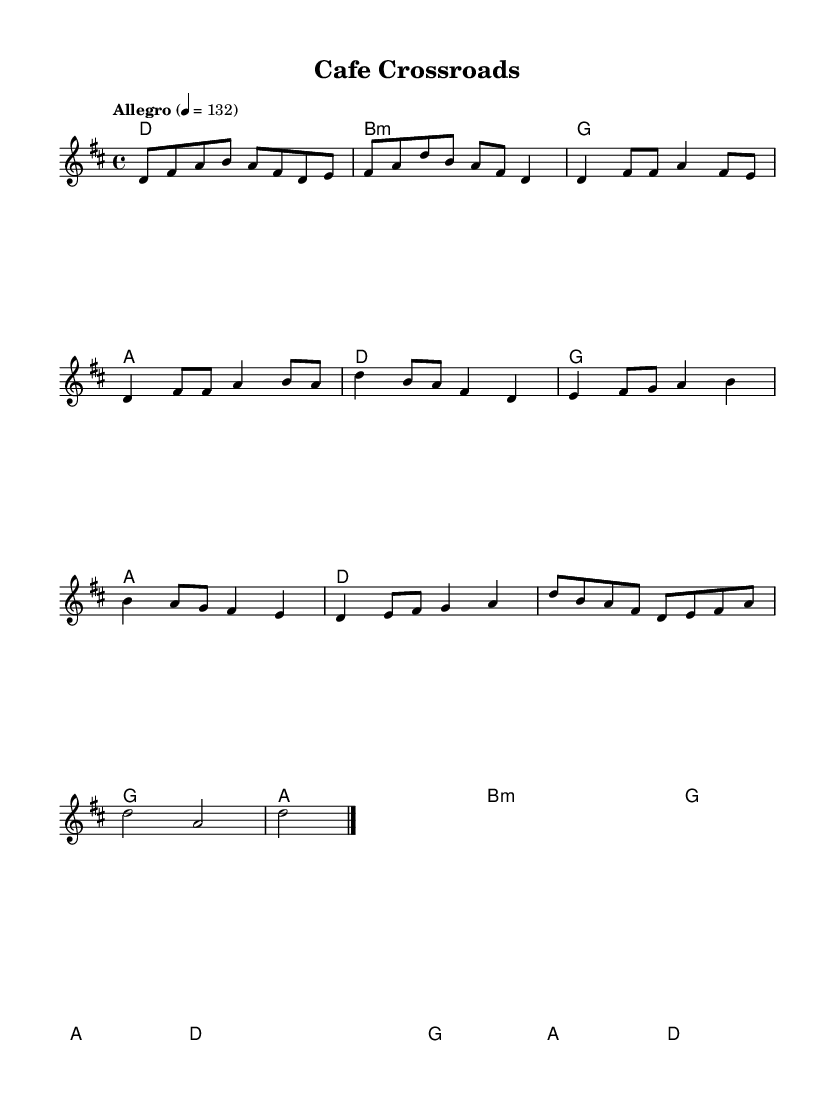What is the key signature of this music? The key signature is D major, indicated by two sharps (F# and C#) in the beginning of the staff.
Answer: D major What is the time signature of this piece? The time signature is 4/4, meaning there are four beats in a measure and the quarter note receives one beat, which is noted at the beginning of the score.
Answer: 4/4 What is the tempo marking for this music? The tempo marking is "Allegro," which describes the speed of the piece as lively and fast, noted alongside the metronome marking of quarter note equals 132.
Answer: Allegro How many measures are in the Chorus section? The Chorus section consists of four measures, which can be identified by counting the measures marked in the score under the heading 'Chorus.'
Answer: 4 What is the final note in the melody? The final note in the melody is a D, as indicated by the notation on the last staff where the melody concludes on this note.
Answer: D Which chord is played during the Bridge section? The first chord in the Bridge section is a B minor chord, indicated by the chord symbol and selected harmonies in the score.
Answer: B minor 